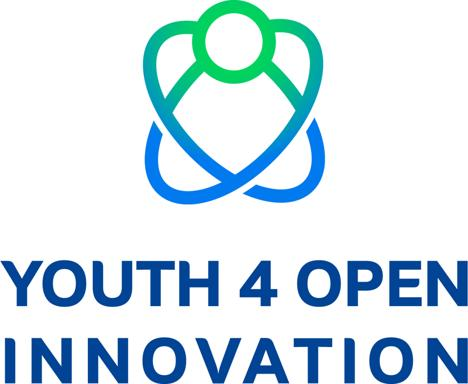Can you describe the design of the logo? The logo is designed with a dynamic and modern aesthetic, featuring a harmonious blue and green color palette. The central element is a stylized representation of a human figure, which is formed using continuous lines that also create an abstract impression of connectivity and openness. The figure appears to be in motion, signifying activity and growth. The words 'YOUTH 4 OPEN INNOVATION' are prominently displayed beneath the emblem in bold, uppercase lettering, further emphasizing the logo's association with youthful energy and the drive towards collaborative progress in innovation. 